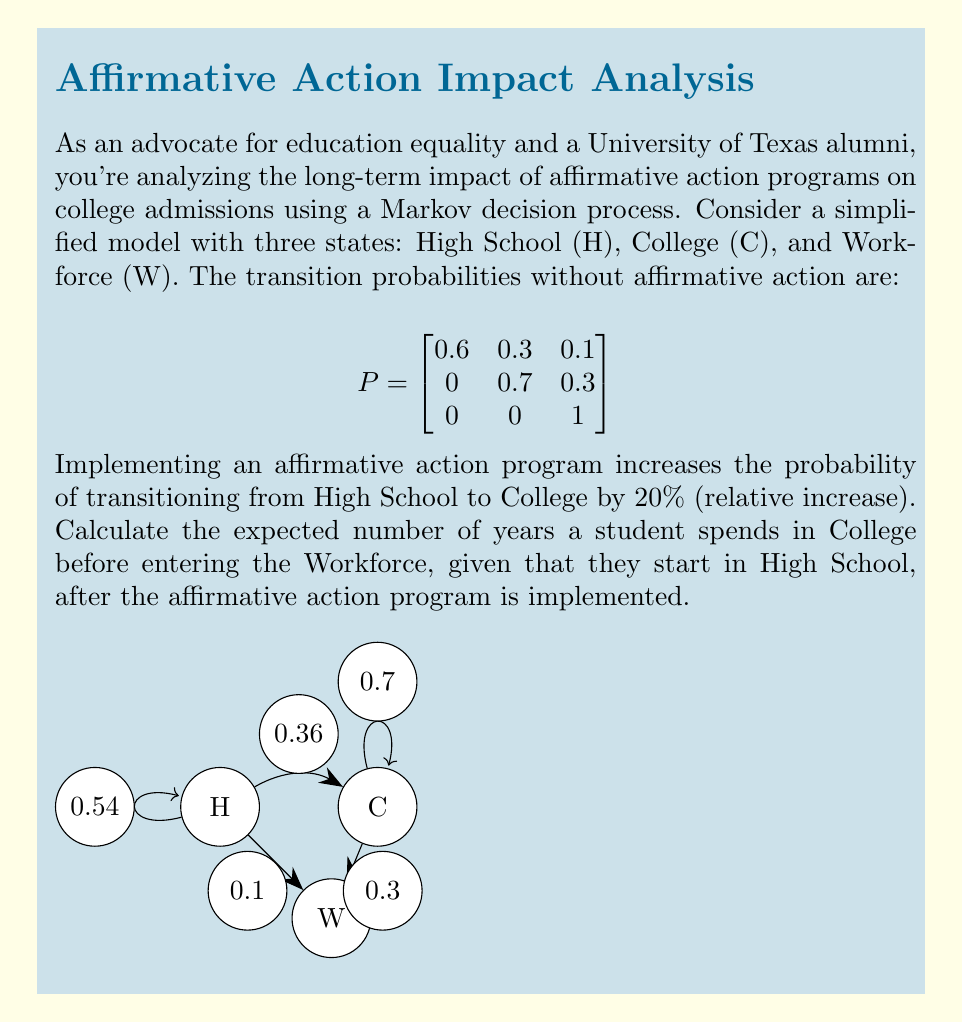Show me your answer to this math problem. Let's approach this step-by-step:

1) First, we need to update the transition matrix with the affirmative action program in place. The probability of transitioning from High School to College increases by 20% relatively:

   $0.3 * 1.2 = 0.36$

2) We need to adjust the probability of staying in High School to maintain the sum of probabilities equal to 1:

   $0.6 - (0.36 - 0.3) = 0.54$

3) The new transition matrix is:

   $$
   P' = \begin{bmatrix}
   0.54 & 0.36 & 0.1 \\
   0 & 0.7 & 0.3 \\
   0 & 0 & 1
   \end{bmatrix}
   $$

4) To find the expected number of years in College, we need to calculate the fundamental matrix $N = (I - Q)^{-1}$, where $Q$ is the submatrix of $P'$ containing only the transient states (H and C):

   $$
   Q = \begin{bmatrix}
   0.54 & 0.36 \\
   0 & 0.7
   \end{bmatrix}
   $$

5) Calculate $I - Q$:

   $$
   I - Q = \begin{bmatrix}
   0.46 & -0.36 \\
   0 & 0.3
   \end{bmatrix}
   $$

6) Find $(I - Q)^{-1}$:

   $$
   N = (I - Q)^{-1} = \begin{bmatrix}
   2.17 & 2.61 \\
   0 & 3.33
   \end{bmatrix}
   $$

7) The expected number of years in College, starting from High School, is given by the entry $N_{1,2} = 2.61$.
Answer: 2.61 years 